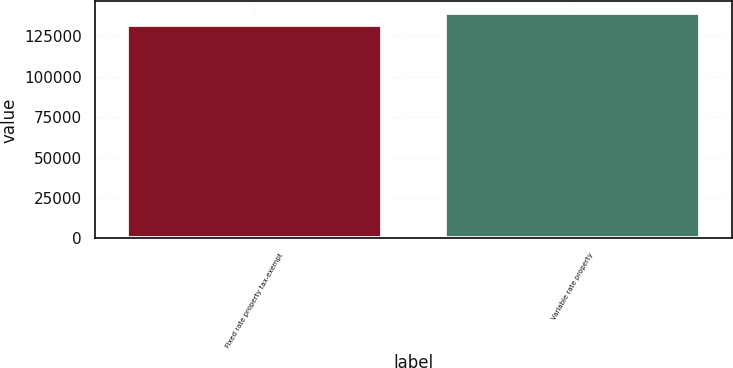Convert chart. <chart><loc_0><loc_0><loc_500><loc_500><bar_chart><fcel>Fixed rate property tax-exempt<fcel>Variable rate property<nl><fcel>132033<fcel>139626<nl></chart> 